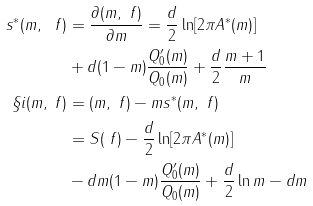Convert formula to latex. <formula><loc_0><loc_0><loc_500><loc_500>s ^ { * } ( m , \ f ) & = \frac { \partial ( m , \ f ) } { \partial m } = \frac { d } 2 \ln [ 2 \pi A ^ { * } ( m ) ] \\ & + d ( 1 - m ) \frac { Q ^ { \prime } _ { 0 } ( m ) } { Q _ { 0 } ( m ) } + \frac { d } { 2 } \frac { m + 1 } m \\ \S i ( m , \ f ) & = ( m , \ f ) - m s ^ { * } ( m , \ f ) \\ & = S ( \ f ) - \frac { d } 2 \ln [ 2 \pi A ^ { * } ( m ) ] \\ & - d m ( 1 - m ) \frac { Q ^ { \prime } _ { 0 } ( m ) } { Q _ { 0 } ( m ) } + \frac { d } 2 \ln m - d m</formula> 